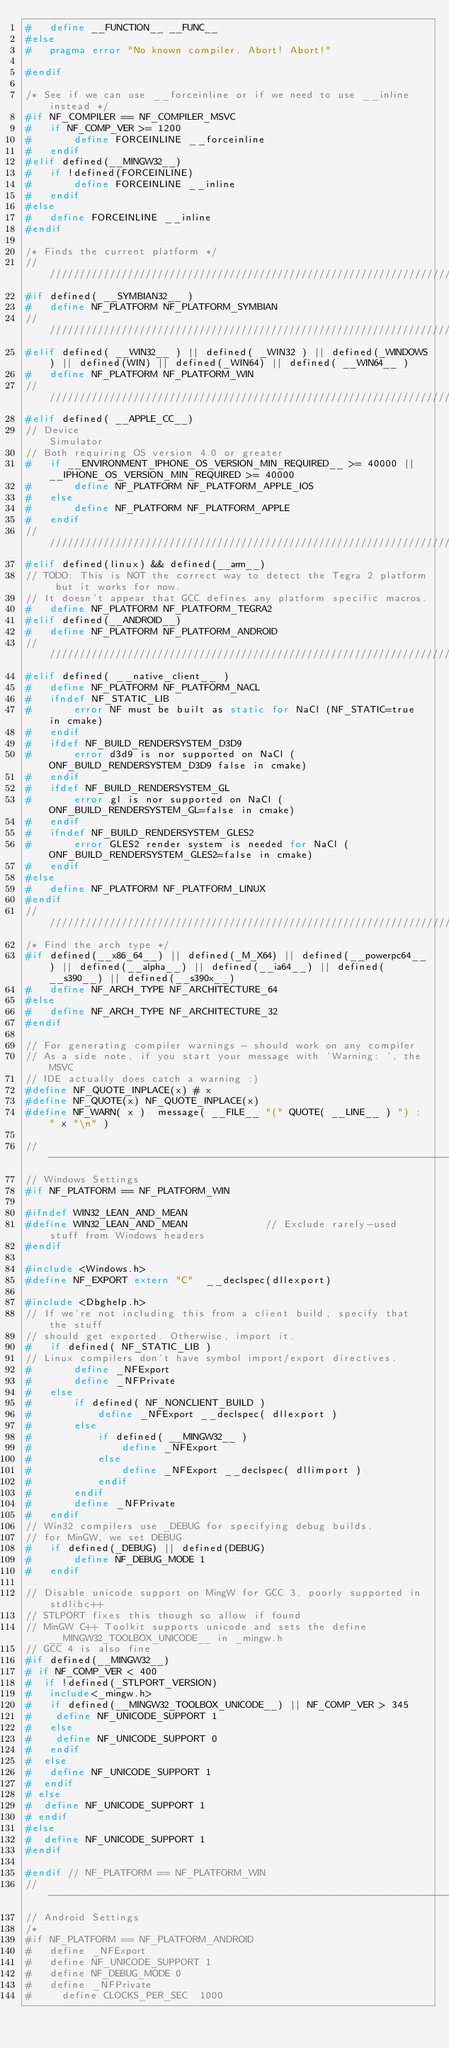<code> <loc_0><loc_0><loc_500><loc_500><_C_>#   define __FUNCTION__ __FUNC__
#else
#   pragma error "No known compiler. Abort! Abort!"

#endif

/* See if we can use __forceinline or if we need to use __inline instead */
#if NF_COMPILER == NF_COMPILER_MSVC
#   if NF_COMP_VER >= 1200
#       define FORCEINLINE __forceinline
#   endif
#elif defined(__MINGW32__)
#   if !defined(FORCEINLINE)
#       define FORCEINLINE __inline
#   endif
#else
#   define FORCEINLINE __inline
#endif

/* Finds the current platform */
////////////////////////////////////////////////////////////////////////////////////////////////////////////////////////////////////////////////////
#if defined( __SYMBIAN32__ )
#   define NF_PLATFORM NF_PLATFORM_SYMBIAN
//////////////////////////////////////////////////////////////////////////
#elif defined( __WIN32__ ) || defined( _WIN32 ) || defined(_WINDOWS) || defined(WIN) || defined(_WIN64) || defined( __WIN64__ )
#   define NF_PLATFORM NF_PLATFORM_WIN
//////////////////////////////////////////////////////////////////////////
#elif defined( __APPLE_CC__)
// Device                                                     Simulator
// Both requiring OS version 4.0 or greater
#   if __ENVIRONMENT_IPHONE_OS_VERSION_MIN_REQUIRED__ >= 40000 || __IPHONE_OS_VERSION_MIN_REQUIRED >= 40000
#       define NF_PLATFORM NF_PLATFORM_APPLE_IOS
#   else
#       define NF_PLATFORM NF_PLATFORM_APPLE
#   endif
//////////////////////////////////////////////////////////////////////////
#elif defined(linux) && defined(__arm__)
// TODO: This is NOT the correct way to detect the Tegra 2 platform but it works for now.
// It doesn't appear that GCC defines any platform specific macros.
#   define NF_PLATFORM NF_PLATFORM_TEGRA2
#elif defined(__ANDROID__)
#   define NF_PLATFORM NF_PLATFORM_ANDROID
//////////////////////////////////////////////////////////////////////////
#elif defined( __native_client__ )
#   define NF_PLATFORM NF_PLATFORM_NACL
#   ifndef NF_STATIC_LIB
#       error NF must be built as static for NaCl (NF_STATIC=true in cmake)
#   endif
#   ifdef NF_BUILD_RENDERSYSTEM_D3D9
#       error d3d9 is nor supported on NaCl (ONF_BUILD_RENDERSYSTEM_D3D9 false in cmake)
#   endif
#   ifdef NF_BUILD_RENDERSYSTEM_GL
#       error gl is nor supported on NaCl (ONF_BUILD_RENDERSYSTEM_GL=false in cmake)
#   endif
#   ifndef NF_BUILD_RENDERSYSTEM_GLES2
#       error GLES2 render system is needed for NaCl (ONF_BUILD_RENDERSYSTEM_GLES2=false in cmake)
#   endif
#else
#   define NF_PLATFORM NF_PLATFORM_LINUX
#endif
////////////////////////////////////////////////////////////////////////////////////////////////////////////////////////////////////////////////////
/* Find the arch type */
#if defined(__x86_64__) || defined(_M_X64) || defined(__powerpc64__) || defined(__alpha__) || defined(__ia64__) || defined(__s390__) || defined(__s390x__)
#   define NF_ARCH_TYPE NF_ARCHITECTURE_64
#else
#   define NF_ARCH_TYPE NF_ARCHITECTURE_32
#endif

// For generating compiler warnings - should work on any compiler
// As a side note, if you start your message with 'Warning: ', the MSVC
// IDE actually does catch a warning :)
#define NF_QUOTE_INPLACE(x) # x
#define NF_QUOTE(x) NF_QUOTE_INPLACE(x)
#define NF_WARN( x )  message( __FILE__ "(" QUOTE( __LINE__ ) ") : " x "\n" )

//----------------------------------------------------------------------------
// Windows Settings
#if NF_PLATFORM == NF_PLATFORM_WIN

#ifndef WIN32_LEAN_AND_MEAN
#define WIN32_LEAN_AND_MEAN             // Exclude rarely-used stuff from Windows headers
#endif

#include <Windows.h>
#define NF_EXPORT extern "C"  __declspec(dllexport)

#include <Dbghelp.h>
// If we're not including this from a client build, specify that the stuff
// should get exported. Otherwise, import it.
#   if defined( NF_STATIC_LIB )
// Linux compilers don't have symbol import/export directives.
#       define _NFExport
#       define _NFPrivate
#   else
#       if defined( NF_NONCLIENT_BUILD )
#           define _NFExport __declspec( dllexport )
#       else
#           if defined( __MINGW32__ )
#               define _NFExport
#           else
#               define _NFExport __declspec( dllimport )
#           endif
#       endif
#       define _NFPrivate
#   endif
// Win32 compilers use _DEBUG for specifying debug builds.
// for MinGW, we set DEBUG
#   if defined(_DEBUG) || defined(DEBUG)
#       define NF_DEBUG_MODE 1
#   endif

// Disable unicode support on MingW for GCC 3, poorly supported in stdlibc++
// STLPORT fixes this though so allow if found
// MinGW C++ Toolkit supports unicode and sets the define __MINGW32_TOOLBOX_UNICODE__ in _mingw.h
// GCC 4 is also fine
#if defined(__MINGW32__)
# if NF_COMP_VER < 400
#  if !defined(_STLPORT_VERSION)
#   include<_mingw.h>
#   if defined(__MINGW32_TOOLBOX_UNICODE__) || NF_COMP_VER > 345
#    define NF_UNICODE_SUPPORT 1
#   else
#    define NF_UNICODE_SUPPORT 0
#   endif
#  else
#   define NF_UNICODE_SUPPORT 1
#  endif
# else
#  define NF_UNICODE_SUPPORT 1
# endif
#else
#  define NF_UNICODE_SUPPORT 1
#endif

#endif // NF_PLATFORM == NF_PLATFORM_WIN
//----------------------------------------------------------------------------
// Android Settings
/*
#if NF_PLATFORM == NF_PLATFORM_ANDROID
#   define _NFExport
#   define NF_UNICODE_SUPPORT 1
#   define NF_DEBUG_MODE 0
#   define _NFPrivate
#     define CLOCKS_PER_SEC  1000</code> 